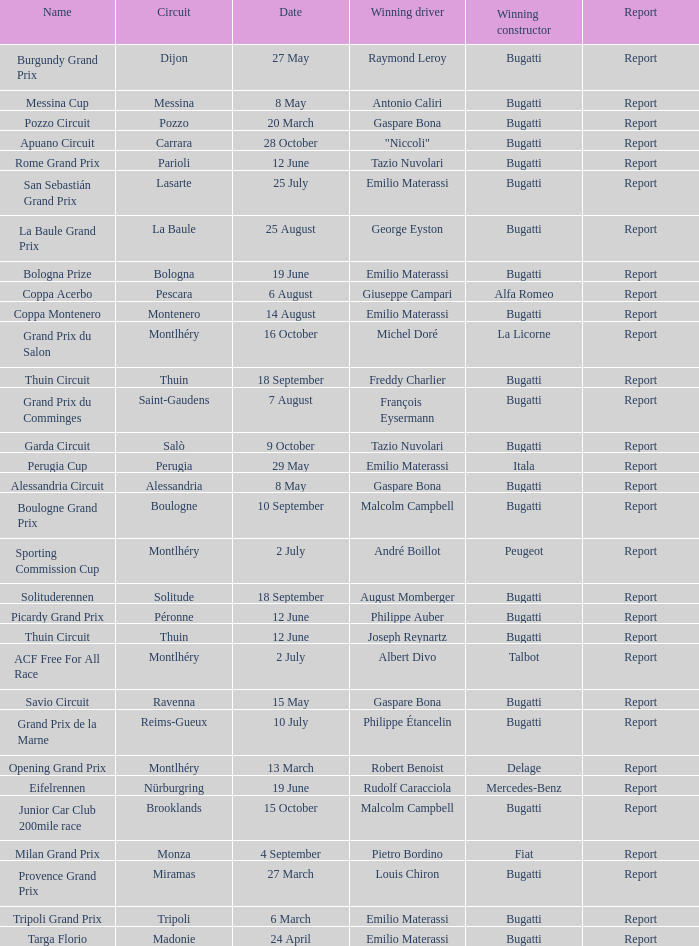Who was the winning constructor at the circuit of parioli? Bugatti. 